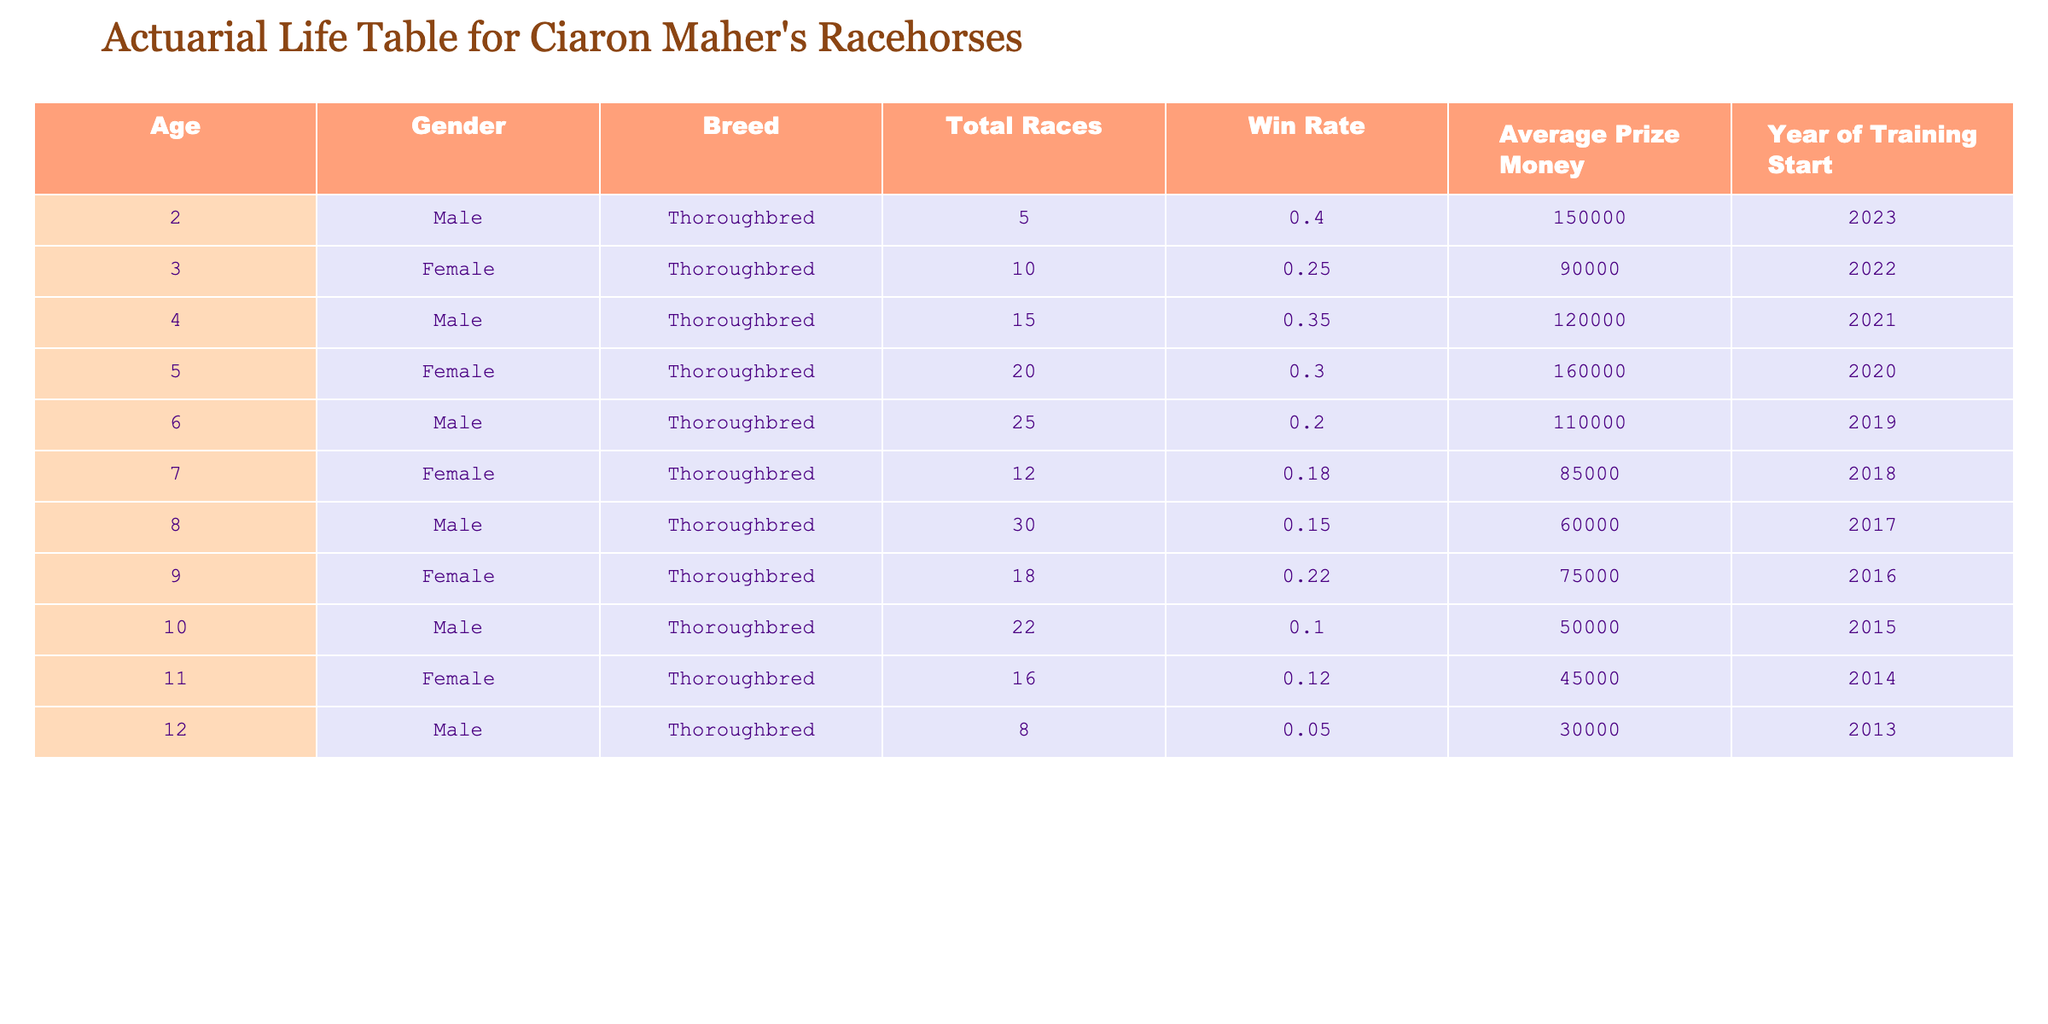What is the win rate of the 4-year-old male racehorse? The table shows that the 4-year-old male racehorse has a win rate listed in the "Win Rate" column. According to the data, the win rate for this horse is 0.35.
Answer: 0.35 How many races did the oldest racehorse, who is 12 years old, participate in? From the table, we look at the "Total Races" column for the 12-year-old horse. It indicates that this horse participated in 8 races.
Answer: 8 What is the average prize money earned by the female racehorses in the table? To find the average prize money for female racehorses, we sum the "Average Prize Money" values for all females: 90000 + 160000 + 85000 + 75000 + 45000 = 415000. There are 5 female racehorses, so the average is 415000 / 5 = 83000.
Answer: 83000 Is there a 5-year-old female horse in the table? By checking the "Age" column, we find that there are no entries for a 5-year-old female horse listed in the table. Thus, the answer is no.
Answer: No What is the total prize money earned by all male racehorses up to 11 years of age? First, we identify all male horses in the table and their corresponding prize money: 150000 (2), 120000 (4), 110000 (6), 60000 (8), 50000 (10), and 30000 (12). We then sum these values: 150000 + 120000 + 110000 + 60000 + 50000 = 490000. Therefore, the total prize money is 490000.
Answer: 490000 How does the average win rate of 3-year-old and older racehorses compare to the average win rate of 2-year-olds? The win rates for the relevant horses are: the 3-year-old (0.25), the 4-year-old (0.35), the 5-year-old (0.30), the 6-year-old (0.20), the 7-year-old (0.18), the 8-year-old (0.15), the 9-year-old (0.22), the 10-year-old (0.10), the 11-year-old (0.12), and the 12-year-old (0.05). The average for the 3-year-olds and older (10 horses) is (0.25 + 0.35 + 0.30 + 0.20 + 0.18 + 0.15 + 0.22 + 0.10 + 0.12 + 0.05) / 10 = 0.177. The average win rate for the 2-year-old solely given in the table is 0.40. Comparing the two, 0.40 is higher than 0.177.
Answer: 0.40 is higher How many different breeds are represented among the racehorses trained by Ciaron Maher? By analyzing the "Breed" column, we see that all entries specify "Thoroughbred." Since there is only one breed mentioned throughout the dataset, the number of different breeds is 1.
Answer: 1 What is the average age of the horses mentioned in the table? To find the average age, we sum up the ages: 2 + 3 + 4 + 5 + 6 + 7 + 8 + 9 + 10 + 11 + 12 = 67. There are 11 horses listed, so we divide 67 by 11, which gives us an average age of approximately 6.09.
Answer: 6.09 